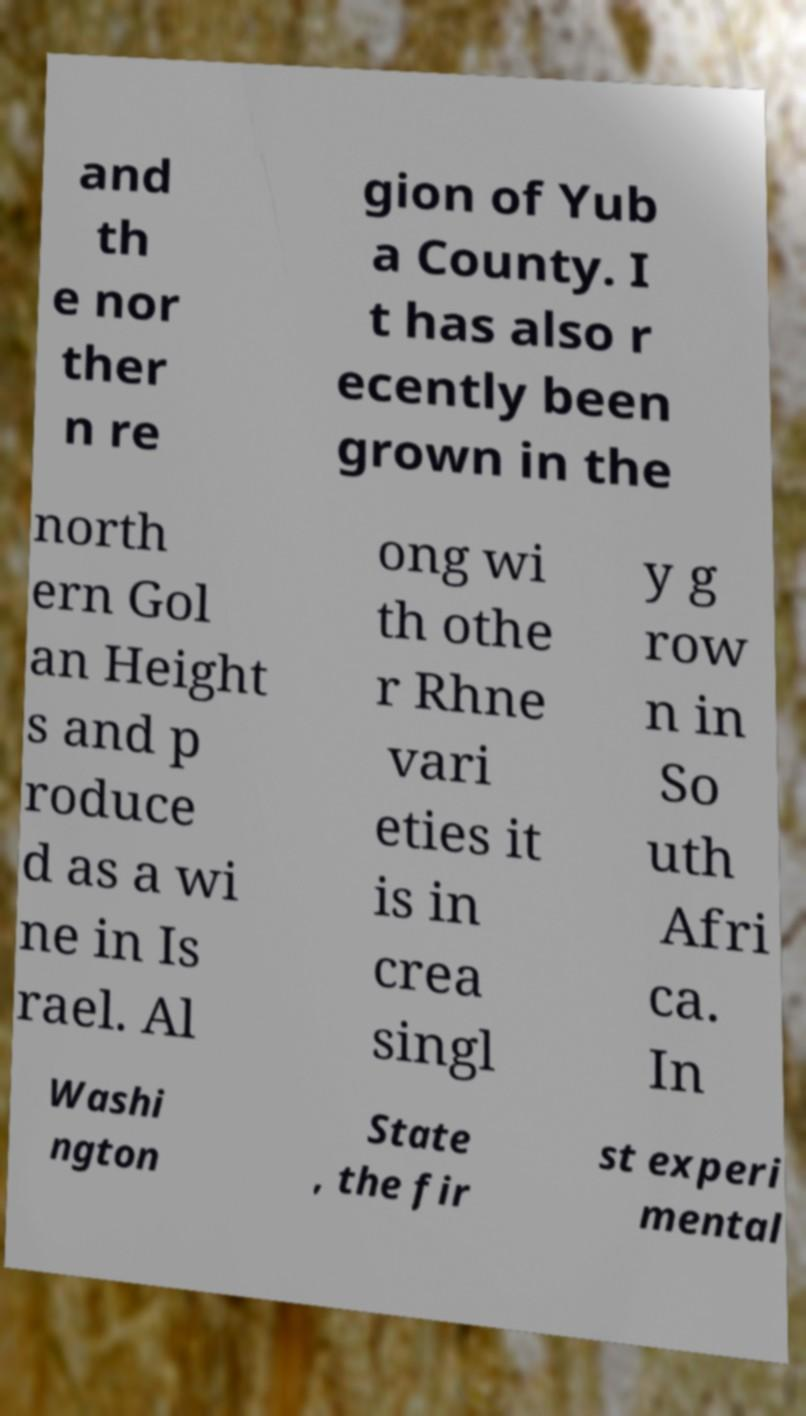Could you extract and type out the text from this image? and th e nor ther n re gion of Yub a County. I t has also r ecently been grown in the north ern Gol an Height s and p roduce d as a wi ne in Is rael. Al ong wi th othe r Rhne vari eties it is in crea singl y g row n in So uth Afri ca. In Washi ngton State , the fir st experi mental 